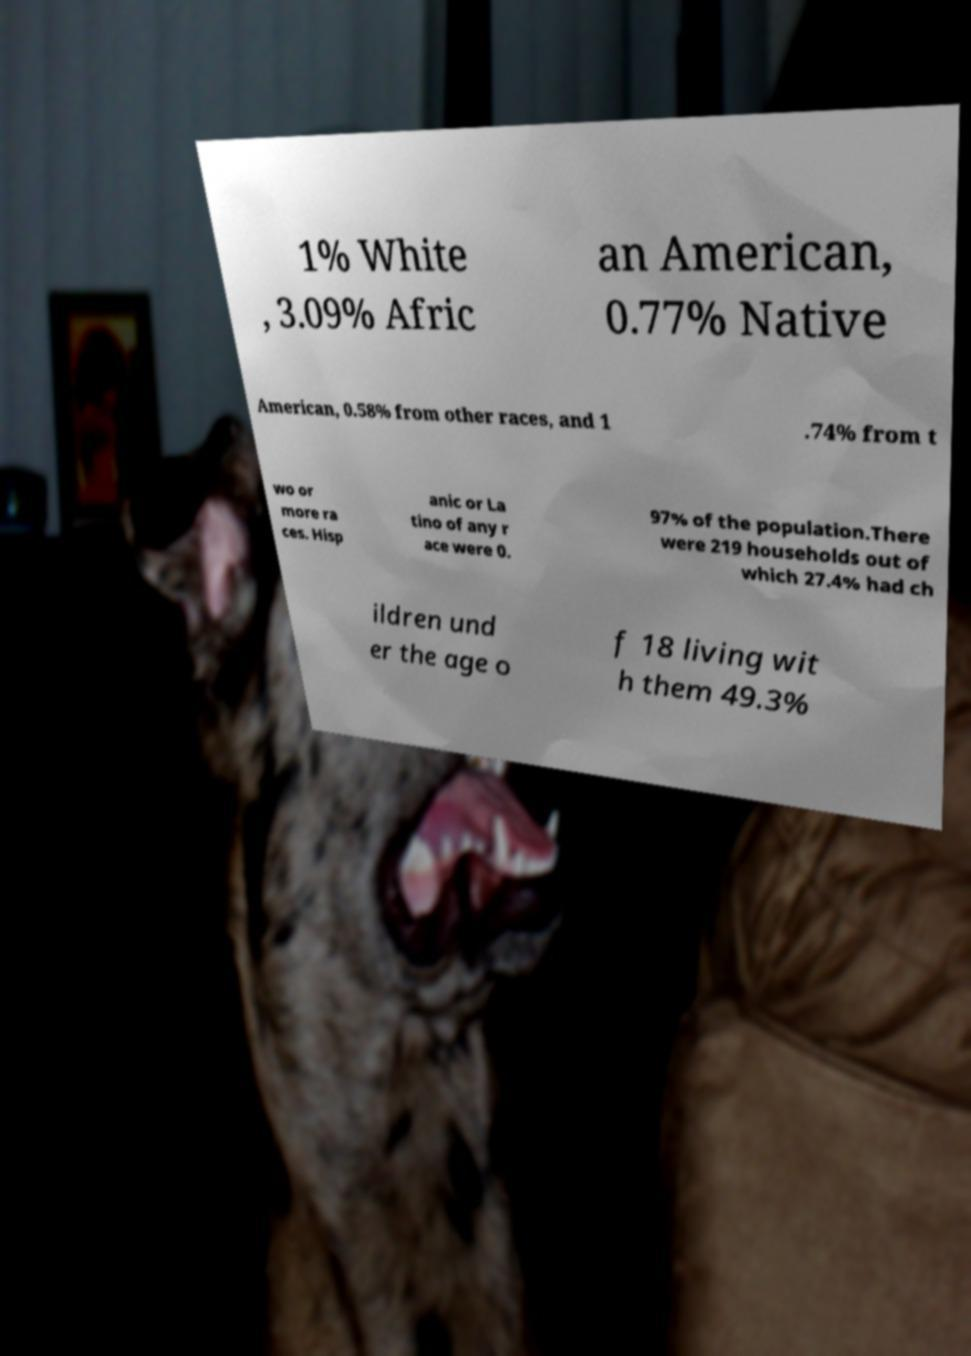Could you extract and type out the text from this image? 1% White , 3.09% Afric an American, 0.77% Native American, 0.58% from other races, and 1 .74% from t wo or more ra ces. Hisp anic or La tino of any r ace were 0. 97% of the population.There were 219 households out of which 27.4% had ch ildren und er the age o f 18 living wit h them 49.3% 